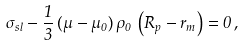Convert formula to latex. <formula><loc_0><loc_0><loc_500><loc_500>\sigma _ { s l } - \frac { 1 } { 3 } \, ( \mu - \mu _ { 0 } ) \, \rho _ { 0 } \, \left ( R _ { p } - r _ { m } \right ) = 0 \, ,</formula> 